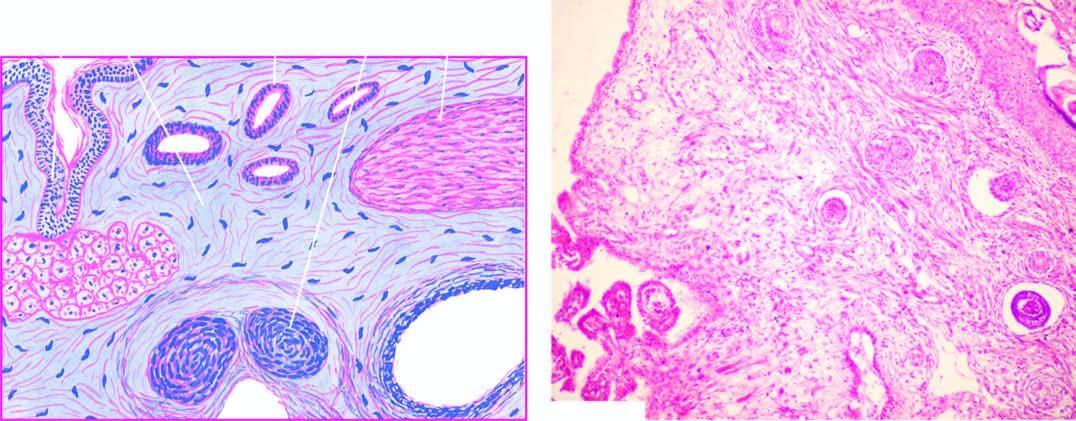does microscopy show a variety of incompletely differentiated tissue elements?
Answer the question using a single word or phrase. Yes 